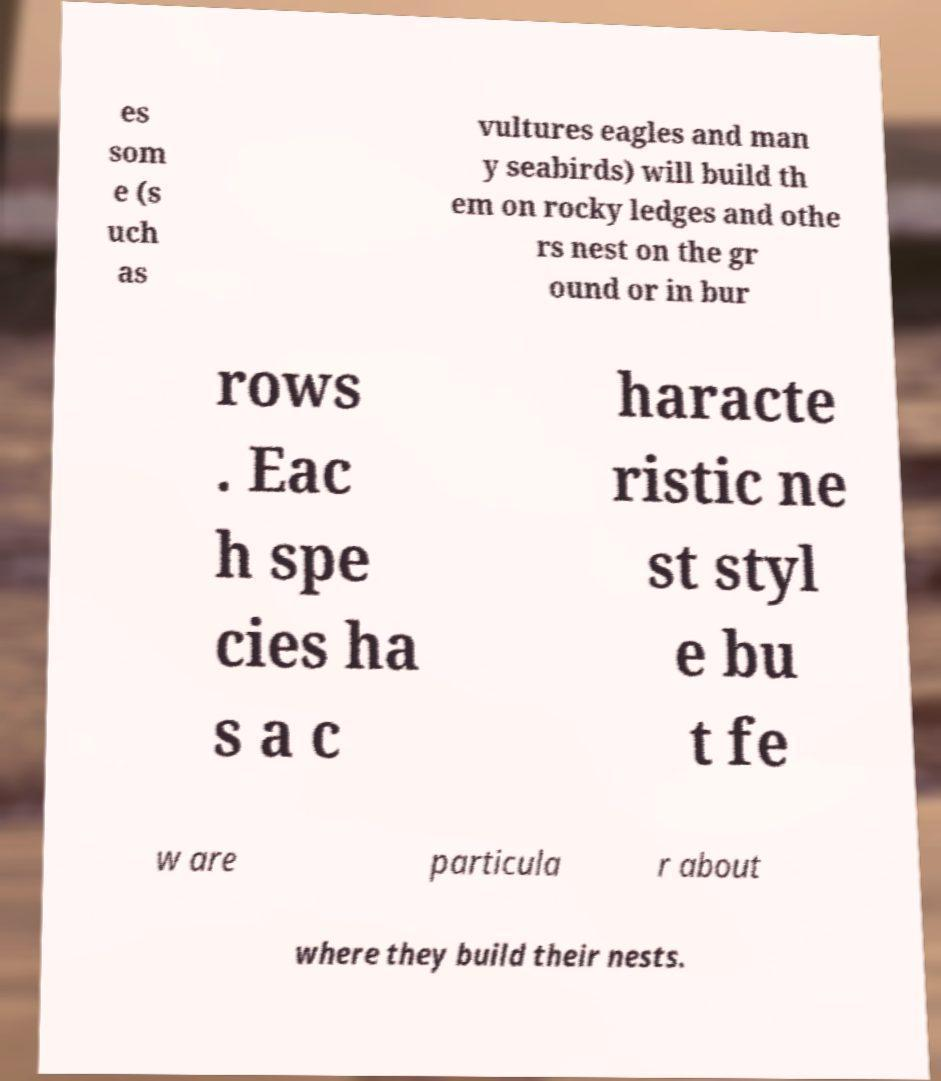Please read and relay the text visible in this image. What does it say? es som e (s uch as vultures eagles and man y seabirds) will build th em on rocky ledges and othe rs nest on the gr ound or in bur rows . Eac h spe cies ha s a c haracte ristic ne st styl e bu t fe w are particula r about where they build their nests. 